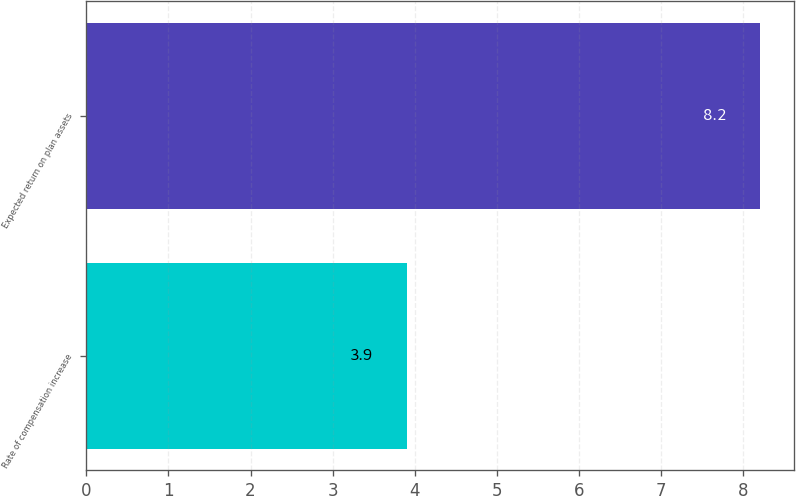Convert chart to OTSL. <chart><loc_0><loc_0><loc_500><loc_500><bar_chart><fcel>Rate of compensation increase<fcel>Expected return on plan assets<nl><fcel>3.9<fcel>8.2<nl></chart> 